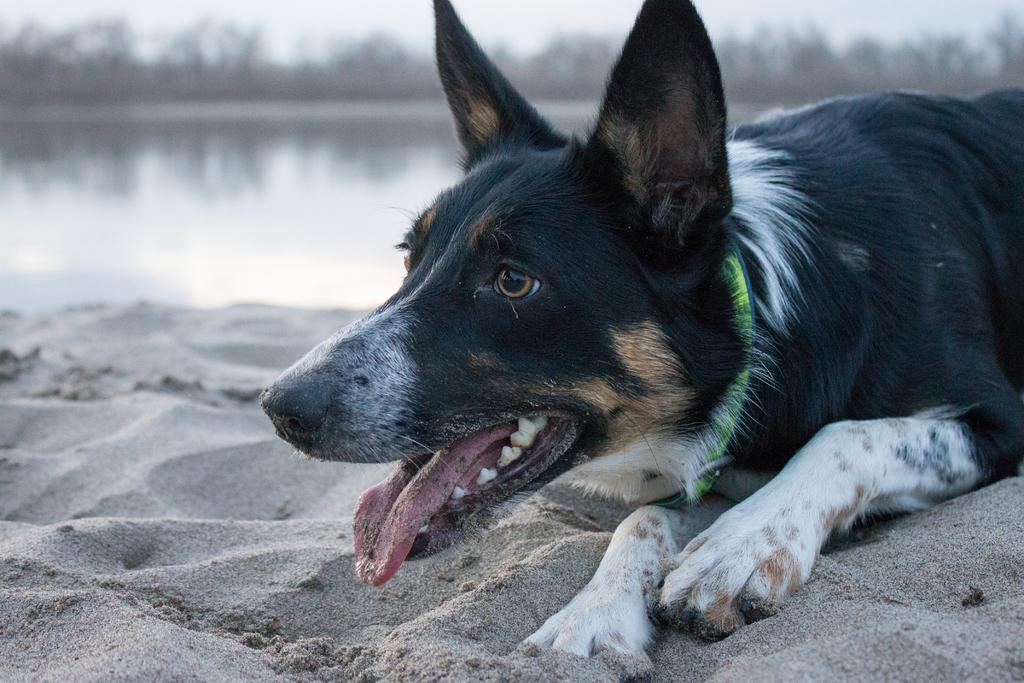What animal can be seen in the image? There is a dog in the image. What position is the dog in? The dog is laying down. What type of terrain is visible at the bottom of the image? There is sand at the bottom of the image. What can be seen in the distance in the image? There is water visible in the background of the image. How would you describe the clarity of the background in the image? The background of the image is blurry. What type of eggs can be seen being offered to the dog in the image? There are no eggs present in the image, nor is there any indication that the dog is being offered anything. 